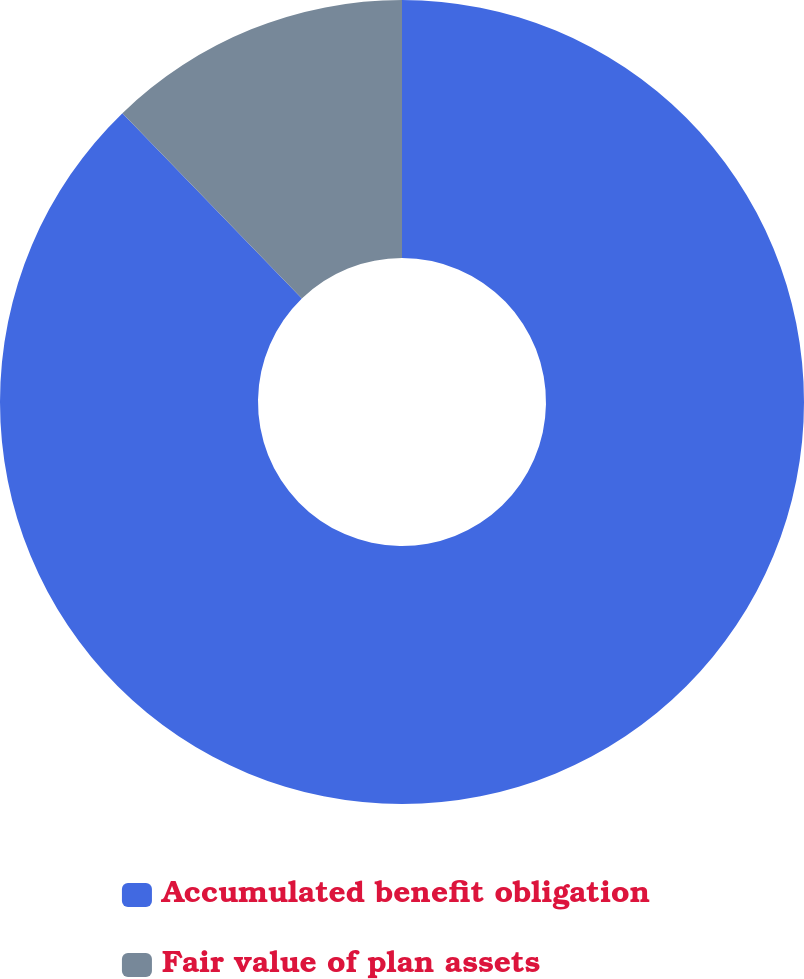Convert chart to OTSL. <chart><loc_0><loc_0><loc_500><loc_500><pie_chart><fcel>Accumulated benefit obligation<fcel>Fair value of plan assets<nl><fcel>87.76%<fcel>12.24%<nl></chart> 